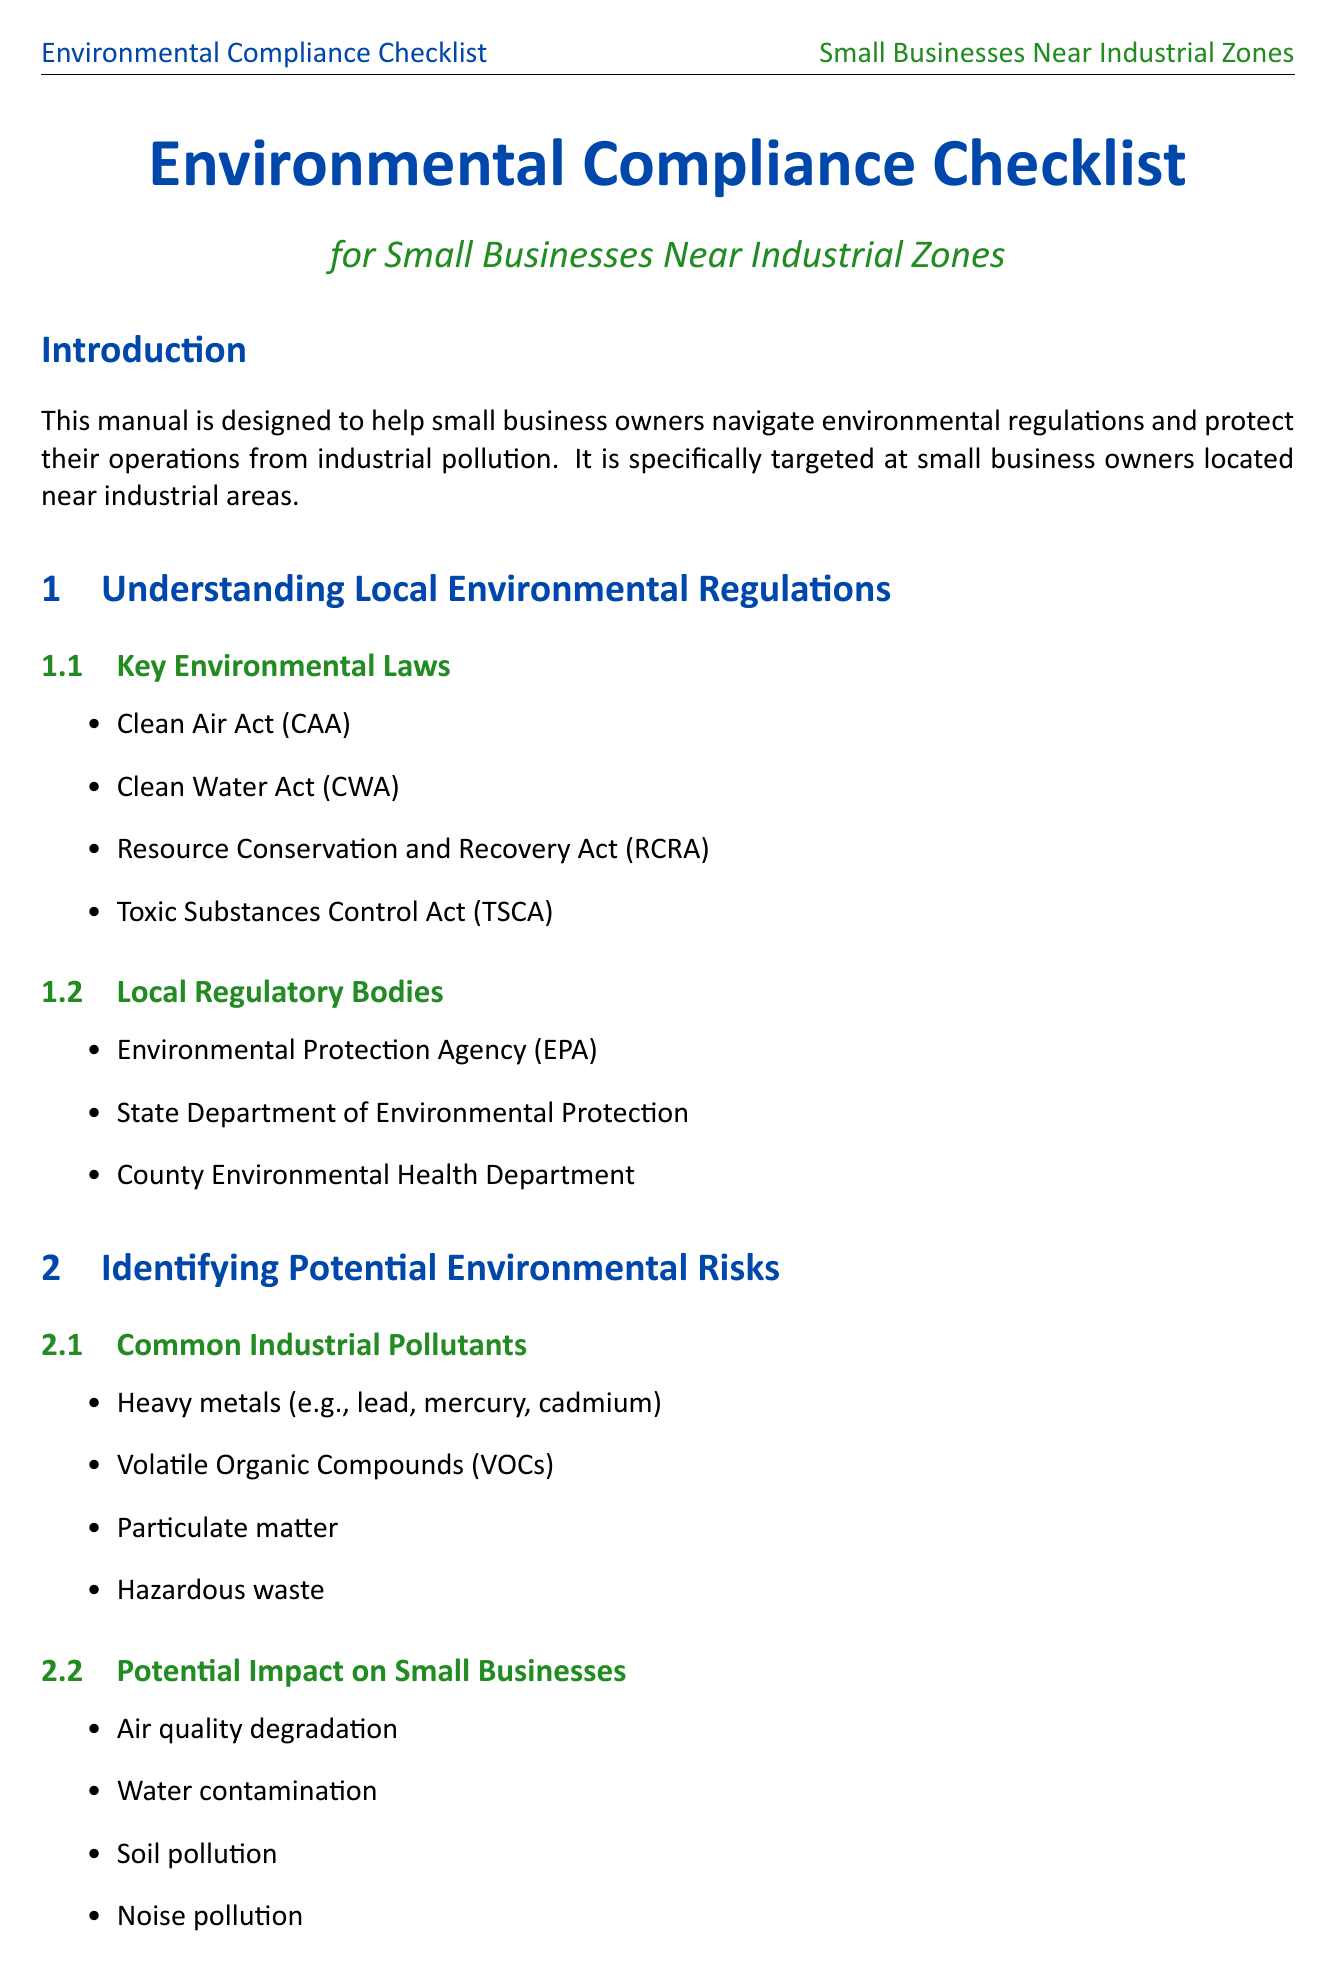What is the purpose of the manual? The purpose of the manual is to assist small business owners in understanding environmental regulations and protecting their operations from industrial pollution.
Answer: To help small business owners navigate environmental regulations and protect their operations from industrial pollution Name one key environmental law mentioned. The document lists several key environmental laws relevant to small businesses, one of which is the Clean Air Act.
Answer: Clean Air Act What type of pollutants should small businesses be aware of? The document identifies common industrial pollutants that could impact small businesses, such as heavy metals.
Answer: Heavy metals Which agency oversees the Toxic Release Inventory program? The document states that businesses should familiarize themselves with the EPA's program regarding toxic releases.
Answer: Environmental Protection Agency (EPA) What is one strategy for advocacy mentioned in the manual? The manual provides strategies for advocacy, including joining local business associations as a proactive measure.
Answer: Join local business associations List one compliance cost that small businesses may incur. The document outlines various compliance costs, one of which includes environmental insurance.
Answer: Environmental insurance How often should environmental audits be conducted? The manual suggests conducting regular environmental audits but does not specify a frequency.
Answer: Regularly What type of funding option is available for small businesses? The document mentions several funding options available, including the EPA Brownfields Program.
Answer: EPA Brownfields Program 